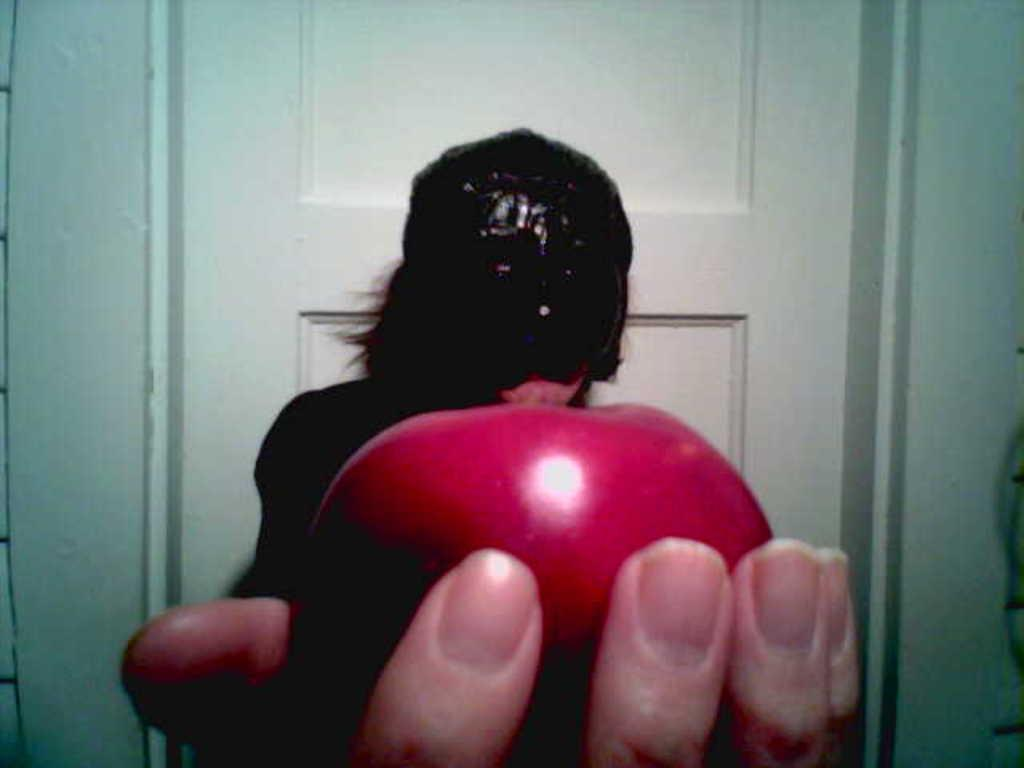Who or what is present in the image? There is a person in the image. What is the person holding? The person is holding an apple. What can be seen in the background of the image? There is a door and a wall in the background of the image. What type of pets are visible in the image? There are no pets visible in the image. What material is the door made of in the image? The material of the door is not mentioned in the image, so it cannot be determined. 